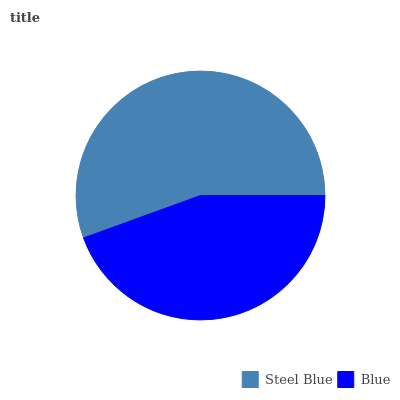Is Blue the minimum?
Answer yes or no. Yes. Is Steel Blue the maximum?
Answer yes or no. Yes. Is Blue the maximum?
Answer yes or no. No. Is Steel Blue greater than Blue?
Answer yes or no. Yes. Is Blue less than Steel Blue?
Answer yes or no. Yes. Is Blue greater than Steel Blue?
Answer yes or no. No. Is Steel Blue less than Blue?
Answer yes or no. No. Is Steel Blue the high median?
Answer yes or no. Yes. Is Blue the low median?
Answer yes or no. Yes. Is Blue the high median?
Answer yes or no. No. Is Steel Blue the low median?
Answer yes or no. No. 